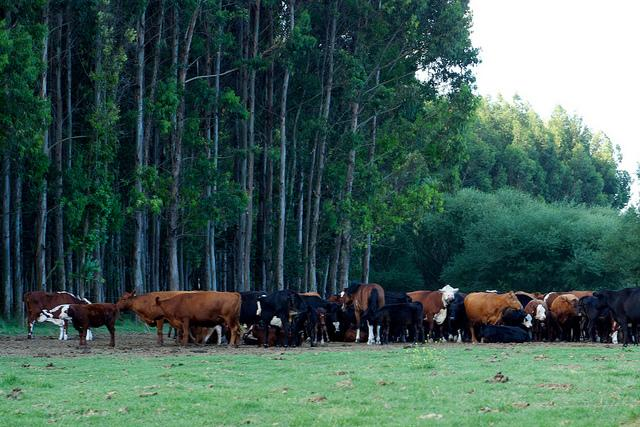What animal are these?

Choices:
A) cow
B) horse
C) donkey
D) goat cow 